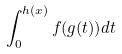<formula> <loc_0><loc_0><loc_500><loc_500>\int _ { 0 } ^ { h ( x ) } f ( g ( t ) ) d t</formula> 